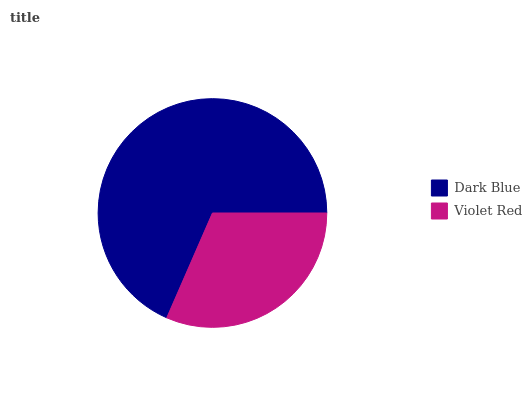Is Violet Red the minimum?
Answer yes or no. Yes. Is Dark Blue the maximum?
Answer yes or no. Yes. Is Violet Red the maximum?
Answer yes or no. No. Is Dark Blue greater than Violet Red?
Answer yes or no. Yes. Is Violet Red less than Dark Blue?
Answer yes or no. Yes. Is Violet Red greater than Dark Blue?
Answer yes or no. No. Is Dark Blue less than Violet Red?
Answer yes or no. No. Is Dark Blue the high median?
Answer yes or no. Yes. Is Violet Red the low median?
Answer yes or no. Yes. Is Violet Red the high median?
Answer yes or no. No. Is Dark Blue the low median?
Answer yes or no. No. 